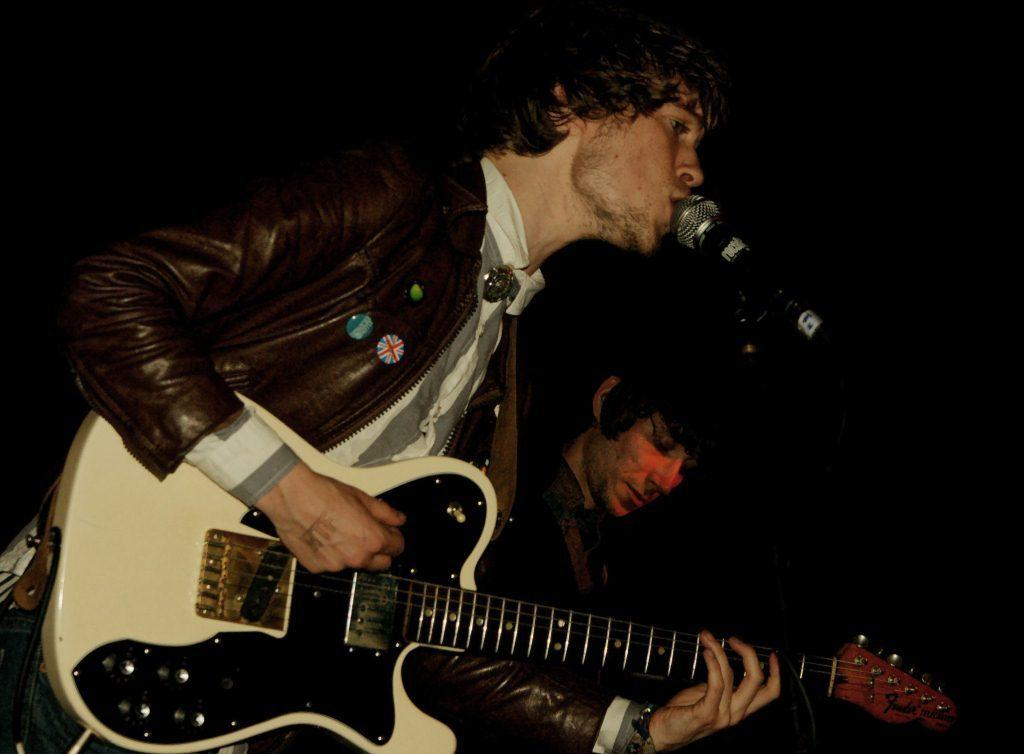How many people are in the image? There are two persons in the image. What is one person doing in the image? One person is playing a guitar. What else is the person playing the guitar doing? The person is also singing into a microphone. What can be observed about the background of the image? The background of the image is dark. How many beds are visible in the image? There are no beds visible in the image. What type of fruit is being used as a prop in the image? There is no fruit, such as a banana, present in the image. 